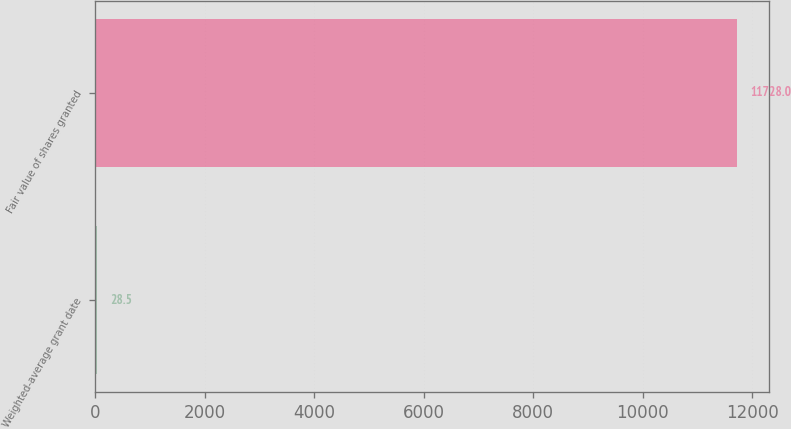<chart> <loc_0><loc_0><loc_500><loc_500><bar_chart><fcel>Weighted-average grant date<fcel>Fair value of shares granted<nl><fcel>28.5<fcel>11728<nl></chart> 